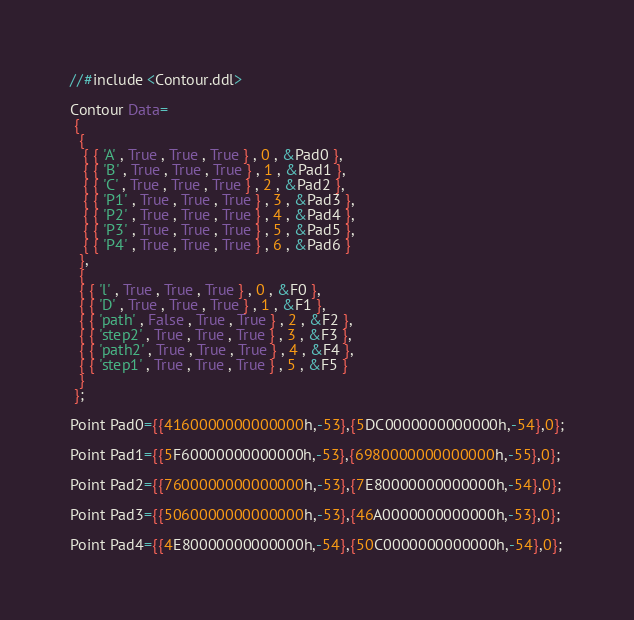<code> <loc_0><loc_0><loc_500><loc_500><_SQL_>//#include <Contour.ddl>

Contour Data=
 {
  {
   { { 'A' , True , True , True } , 0 , &Pad0 },
   { { 'B' , True , True , True } , 1 , &Pad1 },
   { { 'C' , True , True , True } , 2 , &Pad2 },
   { { 'P1' , True , True , True } , 3 , &Pad3 },
   { { 'P2' , True , True , True } , 4 , &Pad4 },
   { { 'P3' , True , True , True } , 5 , &Pad5 },
   { { 'P4' , True , True , True } , 6 , &Pad6 }
  },
  {
  { { 'l' , True , True , True } , 0 , &F0 },
  { { 'D' , True , True , True } , 1 , &F1 },
  { { 'path' , False , True , True } , 2 , &F2 },
  { { 'step2' , True , True , True } , 3 , &F3 },
  { { 'path2' , True , True , True } , 4 , &F4 },
  { { 'step1' , True , True , True } , 5 , &F5 }
  }
 };

Point Pad0={{4160000000000000h,-53},{5DC0000000000000h,-54},0};

Point Pad1={{5F60000000000000h,-53},{6980000000000000h,-55},0};

Point Pad2={{7600000000000000h,-53},{7E80000000000000h,-54},0};

Point Pad3={{5060000000000000h,-53},{46A0000000000000h,-53},0};

Point Pad4={{4E80000000000000h,-54},{50C0000000000000h,-54},0};
</code> 